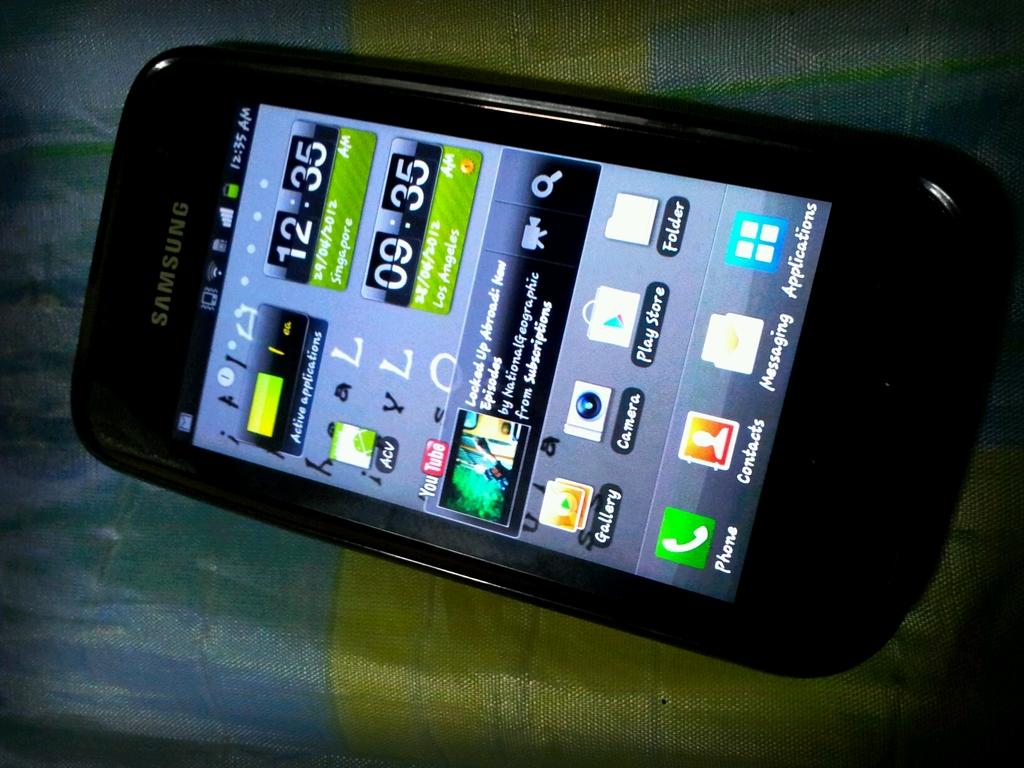Who is the manufacturer of the cell phone?
Your answer should be very brief. Samsung. What time is it in los angeles?
Make the answer very short. 9:35. 